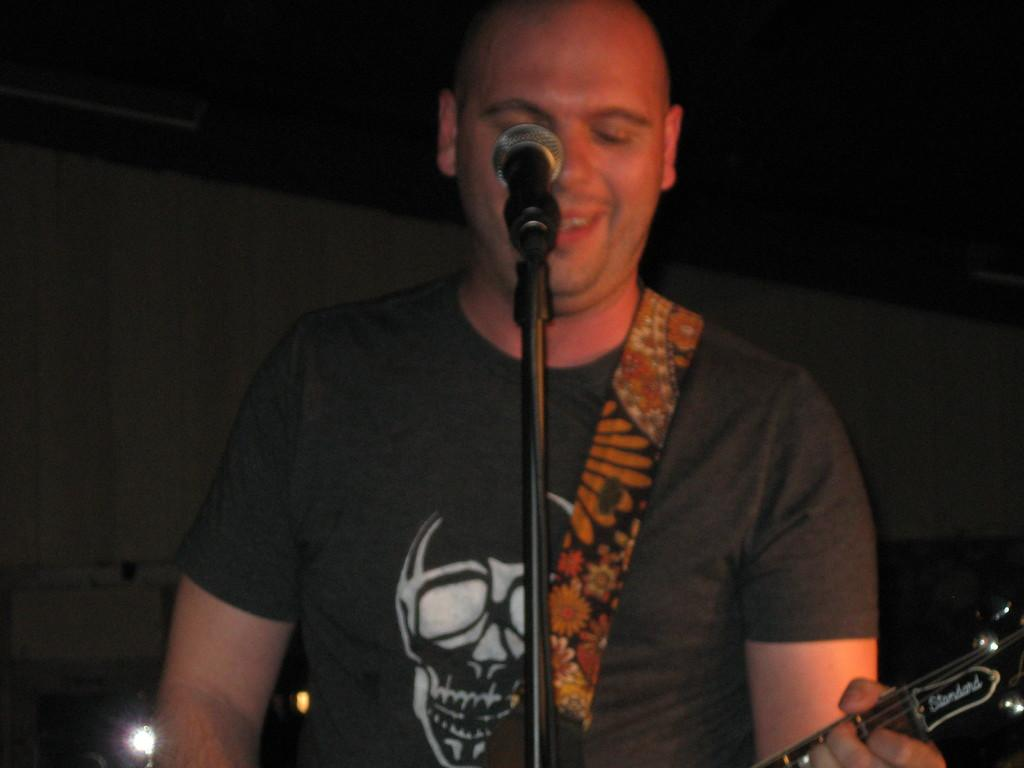Who is the main subject in the image? There is a man in the image. What is the man doing in the image? The man is singing. What is the man holding in his hand? The man is holding a microphone. What instrument is the man playing in the image? The man has a guitar in his hand. What can be observed about the background of the image? The background of the image is dark, and there are lights visible. What type of punishment is the actor receiving in the image? There is no actor present in the image, and no punishment is being administered. Additionally, the image does not depict any learning activities. 